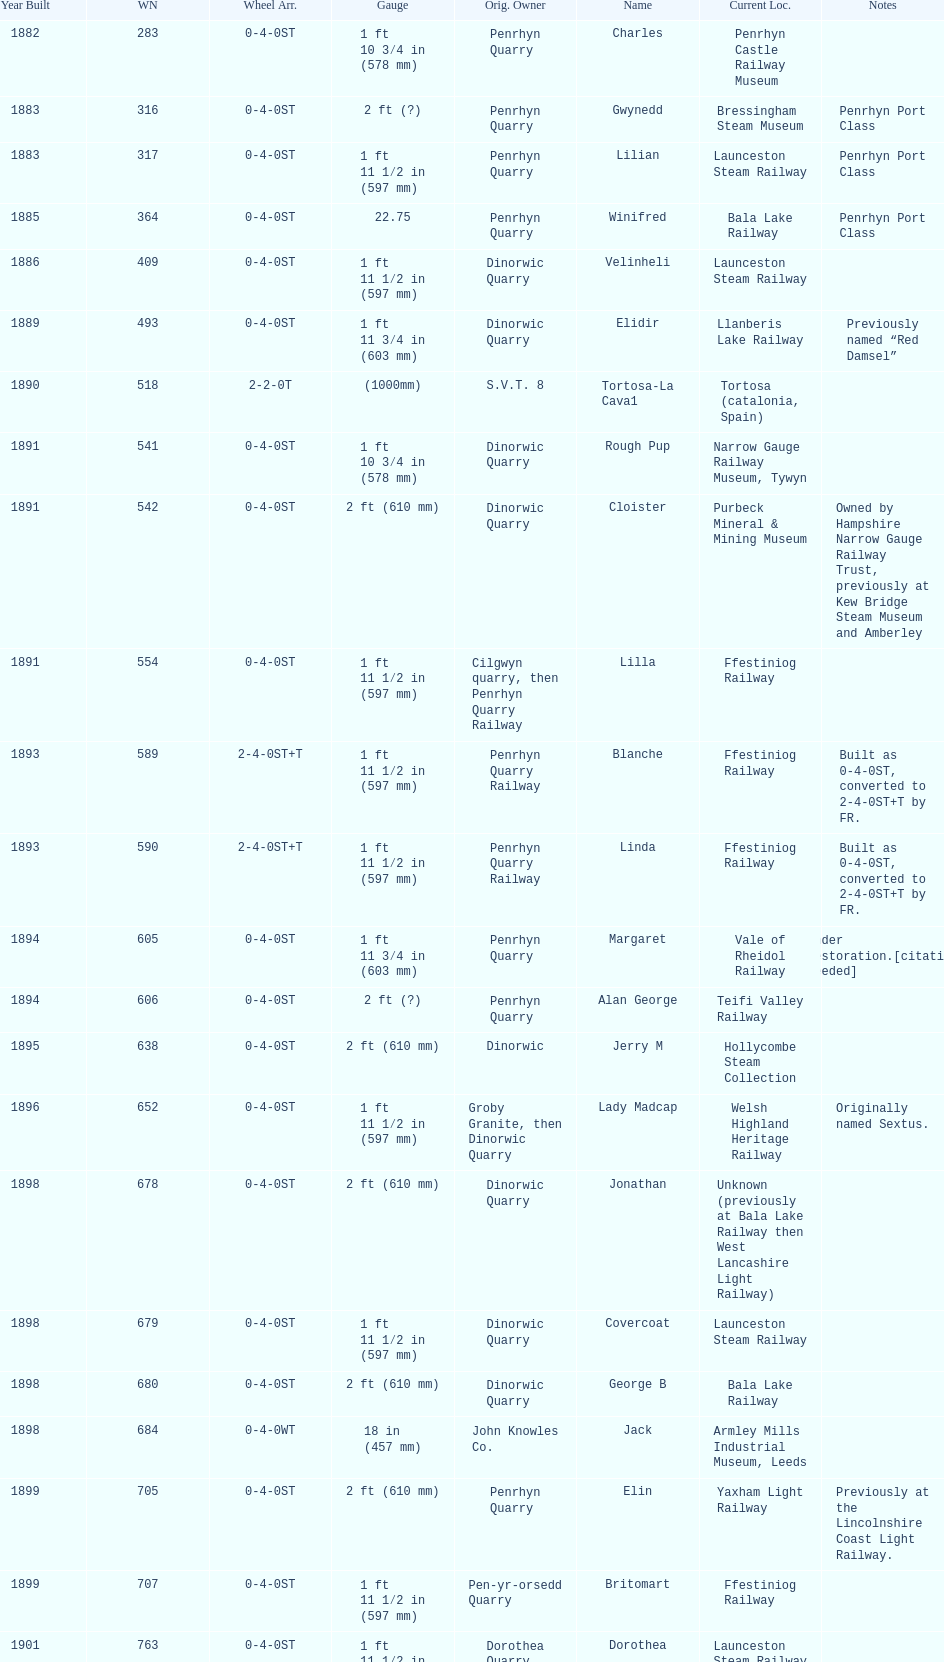What is the difference in gauge between works numbers 541 and 542? 32 mm. 